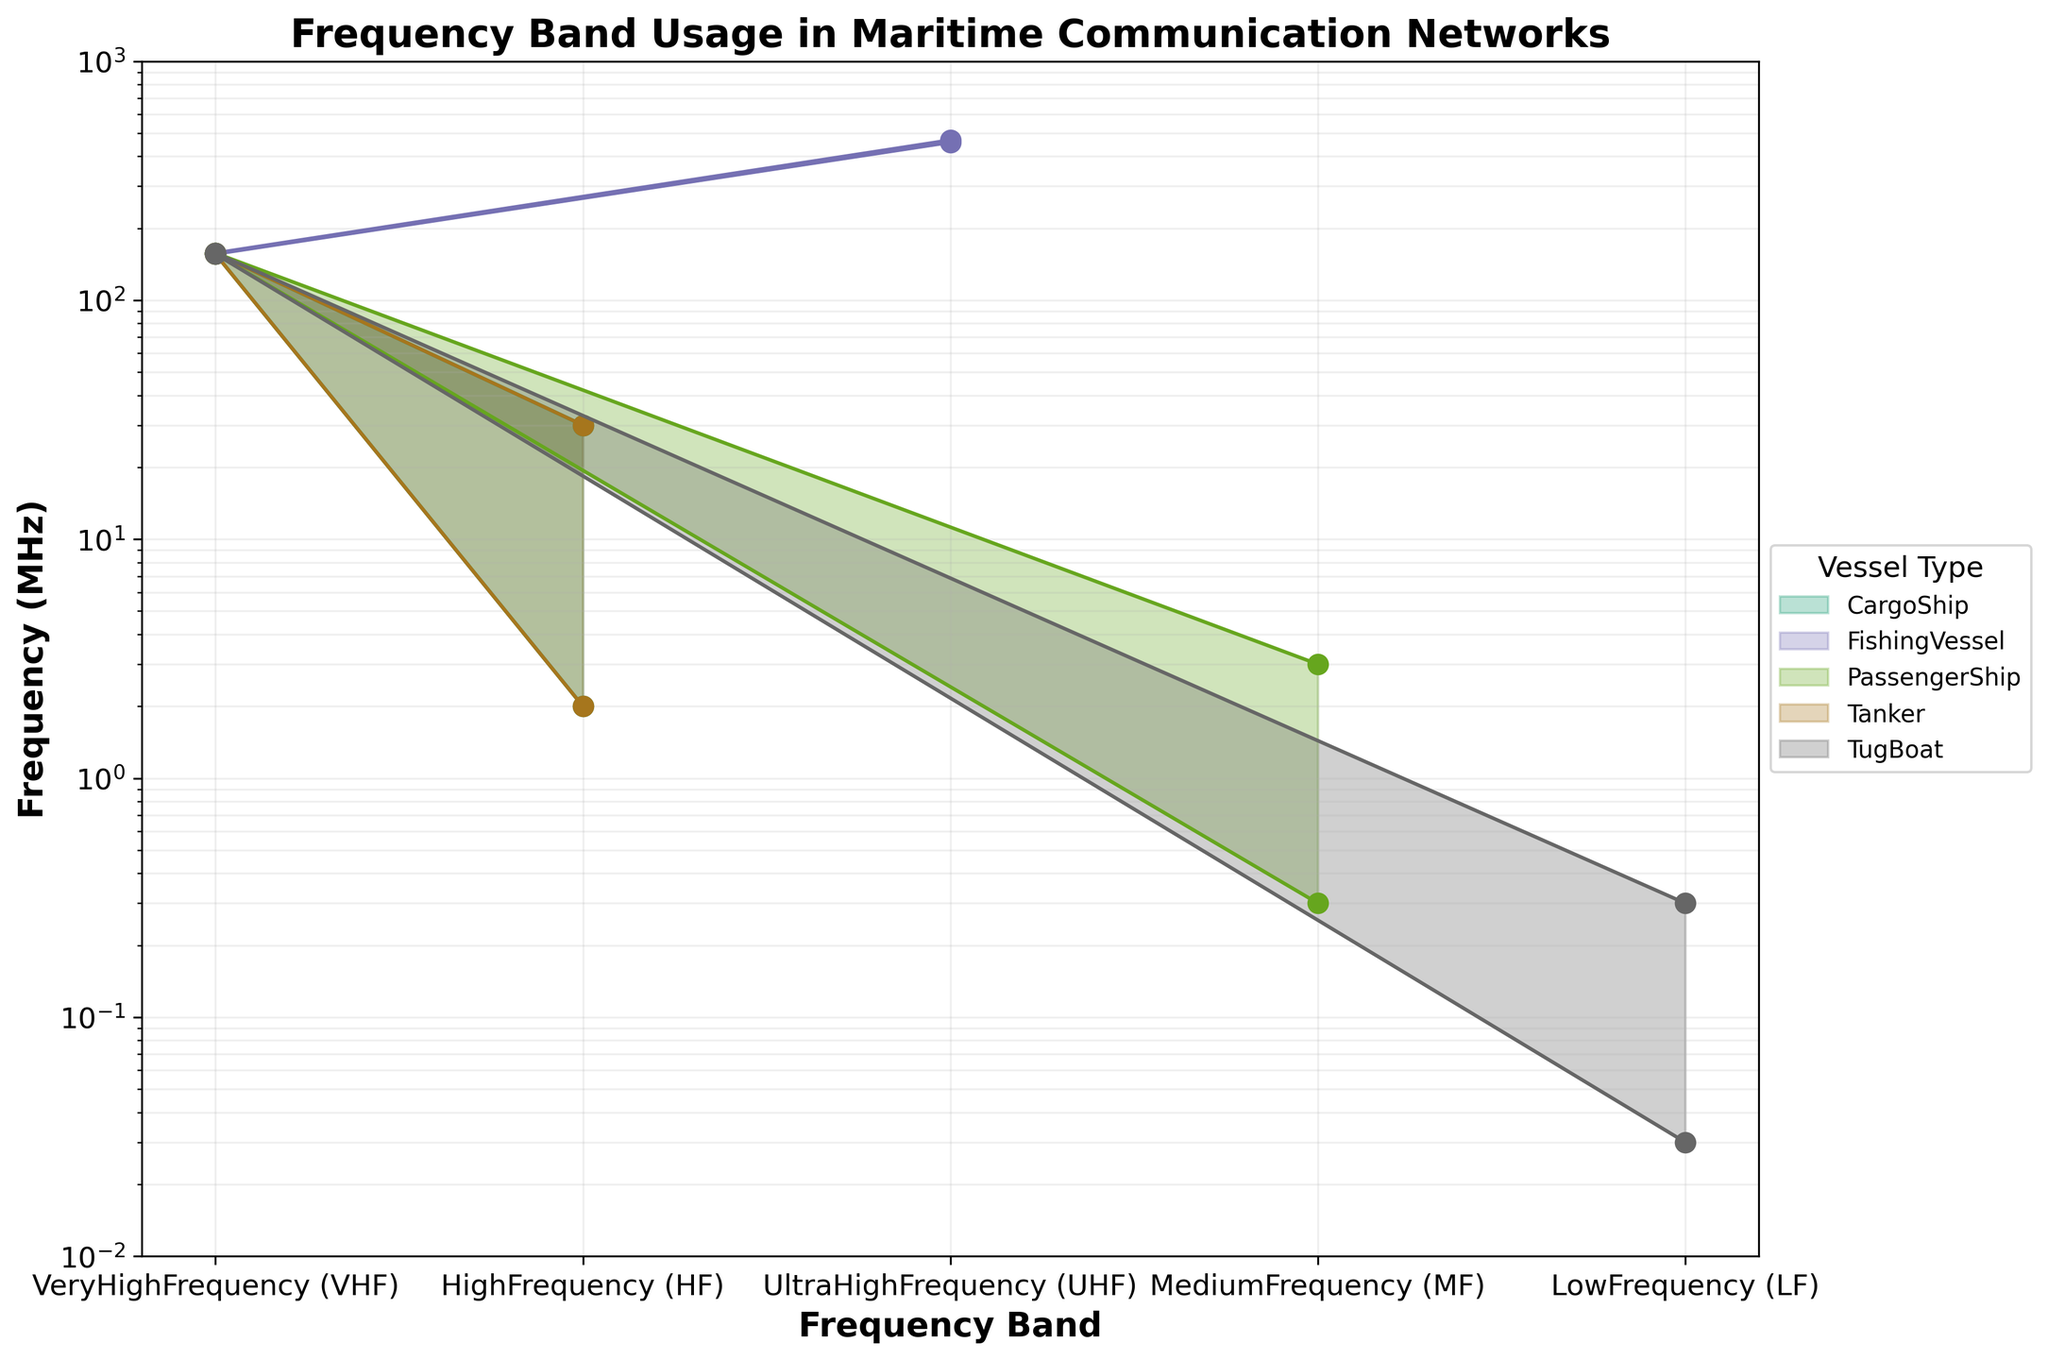What vessel types use the Very High Frequency (VHF) band? Look for the vessel types that have the VHF range shaded in the VHF frequency band section on the plot.
Answer: CargoShip, FishingVessel, PassengerShip, Tanker, TugBoat What is the title of the chart? Read the title text at the top of the figure.
Answer: Frequency Band Usage in Maritime Communication Networks Which vessel type uses the UltraHighFrequency (UHF) band? Check the data to find which vessel type's UHF range is shaded on the plot.
Answer: FishingVessel Which vessel type utilizes the lowest frequency band, and what is that frequency? Find the range shaded to the lowest value on the vertical axis and identify the vessel type and its corresponding frequency.
Answer: TugBoat, 0.03 MHz How many different frequency bands do Cargo Ships use? Count the number of different frequency bands shaded for Cargo Ships in the plot.
Answer: 2 Do Passenger Ships use higher frequencies than Tug Boats? Compare the highest frequencies in the relevant range areas for Passenger Ships and Tug Boats.
Answer: Yes What is the maximum usage frequency for HighFrequency (HF) by Tankers? Look for the top range value for the HF frequency band shaded for Tankers.
Answer: 30.0 MHz Which vessel type operates in the widest frequency range within the HighFrequency (HF) band? Compare the differences between the maximum and minimum usage frequencies for each vessel type within the HF band.
Answer: CargoShip and Tanker Which vessel type has the smallest frequency range usage in the Very HighFrequency (VHF) band? Find the smallest difference between the maximum and minimum frequencies within the VHF band for each vessel type.
Answer: All VHF vessel types How does the usage range of Very High Frequency (VHF) for Cargo Ships compare to that for Passenger Ships? Compare the shaded range areas for VHF for Cargo Ships and Passenger Ships.
Answer: Same 